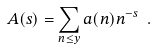<formula> <loc_0><loc_0><loc_500><loc_500>A ( s ) = \sum _ { n \leq y } a ( n ) n ^ { - s } \ .</formula> 